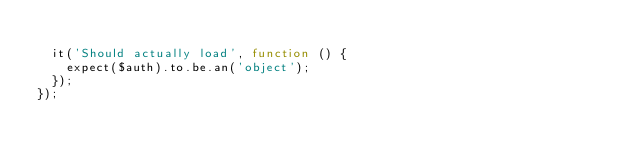Convert code to text. <code><loc_0><loc_0><loc_500><loc_500><_JavaScript_>
  it('Should actually load', function () {
    expect($auth).to.be.an('object');
  });
});
</code> 